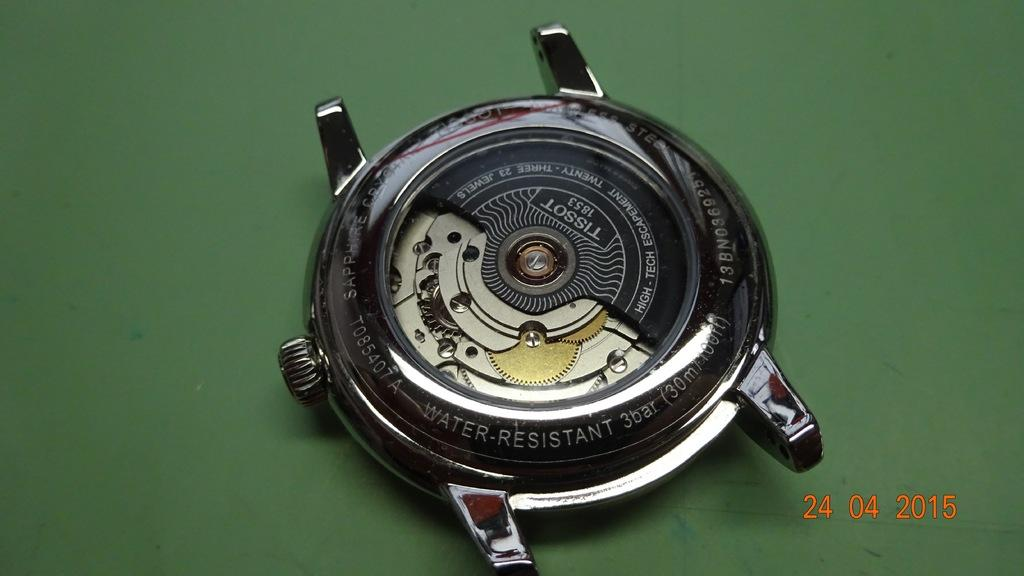<image>
Render a clear and concise summary of the photo. A Tissot brand watch has no band and has the year 1853 under the brand. 